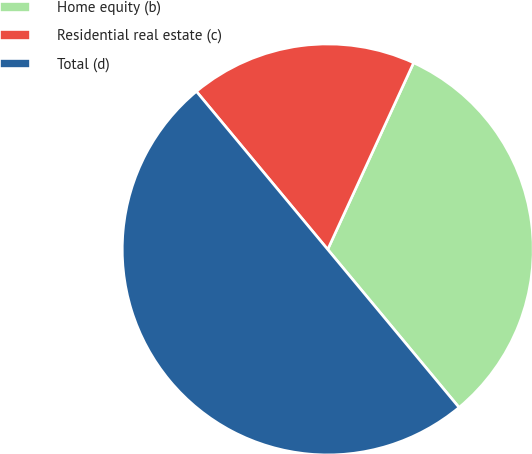Convert chart. <chart><loc_0><loc_0><loc_500><loc_500><pie_chart><fcel>Home equity (b)<fcel>Residential real estate (c)<fcel>Total (d)<nl><fcel>32.1%<fcel>17.9%<fcel>50.0%<nl></chart> 